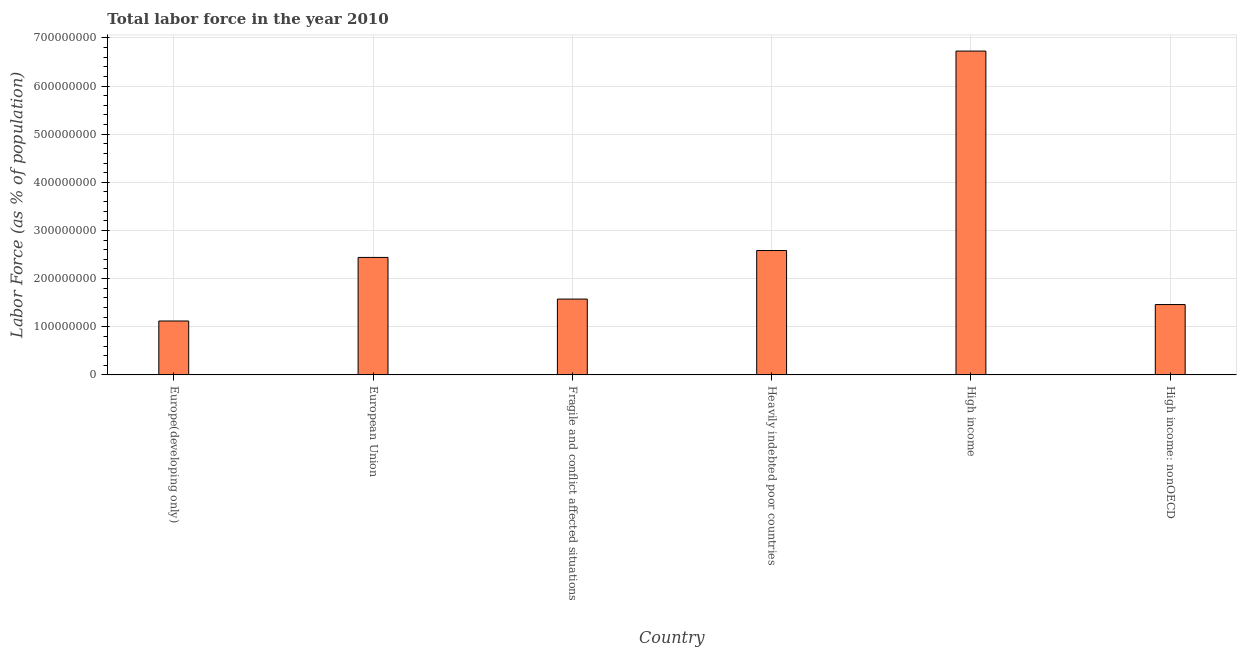Does the graph contain grids?
Offer a terse response. Yes. What is the title of the graph?
Your answer should be compact. Total labor force in the year 2010. What is the label or title of the Y-axis?
Your answer should be compact. Labor Force (as % of population). What is the total labor force in High income: nonOECD?
Your answer should be very brief. 1.46e+08. Across all countries, what is the maximum total labor force?
Your response must be concise. 6.73e+08. Across all countries, what is the minimum total labor force?
Give a very brief answer. 1.12e+08. In which country was the total labor force minimum?
Offer a very short reply. Europe(developing only). What is the sum of the total labor force?
Offer a terse response. 1.59e+09. What is the difference between the total labor force in Europe(developing only) and Fragile and conflict affected situations?
Make the answer very short. -4.56e+07. What is the average total labor force per country?
Provide a short and direct response. 2.65e+08. What is the median total labor force?
Ensure brevity in your answer.  2.01e+08. What is the ratio of the total labor force in Europe(developing only) to that in High income?
Provide a short and direct response. 0.17. Is the difference between the total labor force in Heavily indebted poor countries and High income: nonOECD greater than the difference between any two countries?
Offer a terse response. No. What is the difference between the highest and the second highest total labor force?
Your answer should be very brief. 4.14e+08. Is the sum of the total labor force in Europe(developing only) and Heavily indebted poor countries greater than the maximum total labor force across all countries?
Offer a terse response. No. What is the difference between the highest and the lowest total labor force?
Provide a succinct answer. 5.61e+08. In how many countries, is the total labor force greater than the average total labor force taken over all countries?
Your response must be concise. 1. How many bars are there?
Your answer should be very brief. 6. Are all the bars in the graph horizontal?
Offer a terse response. No. How many countries are there in the graph?
Your answer should be compact. 6. What is the Labor Force (as % of population) of Europe(developing only)?
Provide a succinct answer. 1.12e+08. What is the Labor Force (as % of population) in European Union?
Give a very brief answer. 2.44e+08. What is the Labor Force (as % of population) in Fragile and conflict affected situations?
Make the answer very short. 1.58e+08. What is the Labor Force (as % of population) of Heavily indebted poor countries?
Keep it short and to the point. 2.58e+08. What is the Labor Force (as % of population) of High income?
Keep it short and to the point. 6.73e+08. What is the Labor Force (as % of population) of High income: nonOECD?
Your response must be concise. 1.46e+08. What is the difference between the Labor Force (as % of population) in Europe(developing only) and European Union?
Provide a short and direct response. -1.32e+08. What is the difference between the Labor Force (as % of population) in Europe(developing only) and Fragile and conflict affected situations?
Provide a short and direct response. -4.56e+07. What is the difference between the Labor Force (as % of population) in Europe(developing only) and Heavily indebted poor countries?
Your answer should be compact. -1.46e+08. What is the difference between the Labor Force (as % of population) in Europe(developing only) and High income?
Your response must be concise. -5.61e+08. What is the difference between the Labor Force (as % of population) in Europe(developing only) and High income: nonOECD?
Your answer should be compact. -3.41e+07. What is the difference between the Labor Force (as % of population) in European Union and Fragile and conflict affected situations?
Your answer should be compact. 8.65e+07. What is the difference between the Labor Force (as % of population) in European Union and Heavily indebted poor countries?
Keep it short and to the point. -1.43e+07. What is the difference between the Labor Force (as % of population) in European Union and High income?
Your answer should be very brief. -4.29e+08. What is the difference between the Labor Force (as % of population) in European Union and High income: nonOECD?
Your answer should be compact. 9.79e+07. What is the difference between the Labor Force (as % of population) in Fragile and conflict affected situations and Heavily indebted poor countries?
Make the answer very short. -1.01e+08. What is the difference between the Labor Force (as % of population) in Fragile and conflict affected situations and High income?
Your response must be concise. -5.15e+08. What is the difference between the Labor Force (as % of population) in Fragile and conflict affected situations and High income: nonOECD?
Your response must be concise. 1.14e+07. What is the difference between the Labor Force (as % of population) in Heavily indebted poor countries and High income?
Your answer should be very brief. -4.14e+08. What is the difference between the Labor Force (as % of population) in Heavily indebted poor countries and High income: nonOECD?
Give a very brief answer. 1.12e+08. What is the difference between the Labor Force (as % of population) in High income and High income: nonOECD?
Make the answer very short. 5.27e+08. What is the ratio of the Labor Force (as % of population) in Europe(developing only) to that in European Union?
Offer a very short reply. 0.46. What is the ratio of the Labor Force (as % of population) in Europe(developing only) to that in Fragile and conflict affected situations?
Offer a very short reply. 0.71. What is the ratio of the Labor Force (as % of population) in Europe(developing only) to that in Heavily indebted poor countries?
Your response must be concise. 0.43. What is the ratio of the Labor Force (as % of population) in Europe(developing only) to that in High income?
Offer a very short reply. 0.17. What is the ratio of the Labor Force (as % of population) in Europe(developing only) to that in High income: nonOECD?
Your answer should be compact. 0.77. What is the ratio of the Labor Force (as % of population) in European Union to that in Fragile and conflict affected situations?
Ensure brevity in your answer.  1.55. What is the ratio of the Labor Force (as % of population) in European Union to that in Heavily indebted poor countries?
Keep it short and to the point. 0.94. What is the ratio of the Labor Force (as % of population) in European Union to that in High income?
Your answer should be very brief. 0.36. What is the ratio of the Labor Force (as % of population) in European Union to that in High income: nonOECD?
Make the answer very short. 1.67. What is the ratio of the Labor Force (as % of population) in Fragile and conflict affected situations to that in Heavily indebted poor countries?
Provide a short and direct response. 0.61. What is the ratio of the Labor Force (as % of population) in Fragile and conflict affected situations to that in High income?
Offer a terse response. 0.23. What is the ratio of the Labor Force (as % of population) in Fragile and conflict affected situations to that in High income: nonOECD?
Keep it short and to the point. 1.08. What is the ratio of the Labor Force (as % of population) in Heavily indebted poor countries to that in High income?
Your answer should be compact. 0.38. What is the ratio of the Labor Force (as % of population) in Heavily indebted poor countries to that in High income: nonOECD?
Ensure brevity in your answer.  1.77. What is the ratio of the Labor Force (as % of population) in High income to that in High income: nonOECD?
Provide a succinct answer. 4.6. 